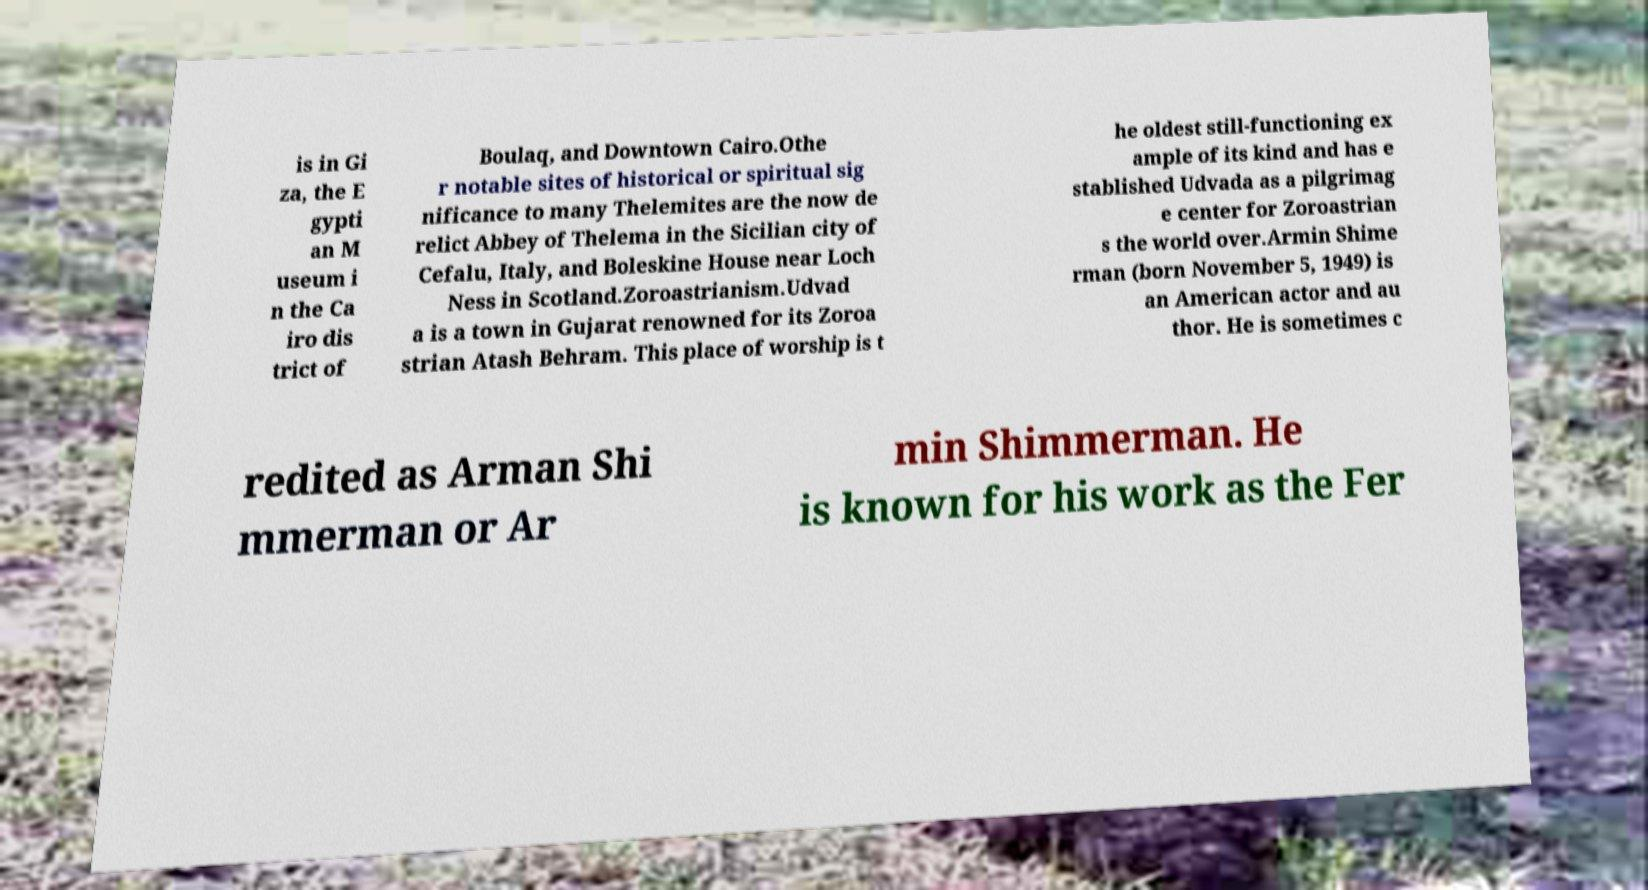What messages or text are displayed in this image? I need them in a readable, typed format. is in Gi za, the E gypti an M useum i n the Ca iro dis trict of Boulaq, and Downtown Cairo.Othe r notable sites of historical or spiritual sig nificance to many Thelemites are the now de relict Abbey of Thelema in the Sicilian city of Cefalu, Italy, and Boleskine House near Loch Ness in Scotland.Zoroastrianism.Udvad a is a town in Gujarat renowned for its Zoroa strian Atash Behram. This place of worship is t he oldest still-functioning ex ample of its kind and has e stablished Udvada as a pilgrimag e center for Zoroastrian s the world over.Armin Shime rman (born November 5, 1949) is an American actor and au thor. He is sometimes c redited as Arman Shi mmerman or Ar min Shimmerman. He is known for his work as the Fer 